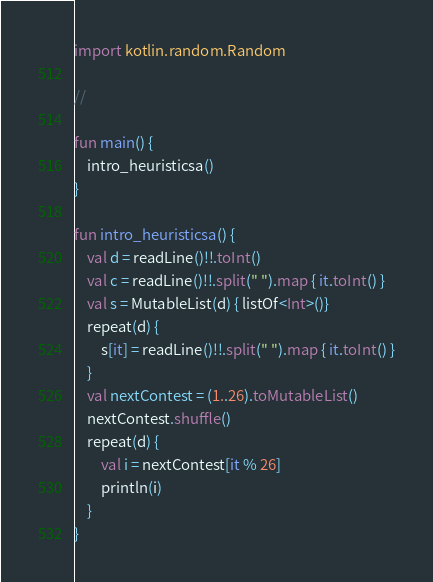Convert code to text. <code><loc_0><loc_0><loc_500><loc_500><_Kotlin_>import kotlin.random.Random

//

fun main() {
    intro_heuristicsa()
}

fun intro_heuristicsa() {
    val d = readLine()!!.toInt()
    val c = readLine()!!.split(" ").map { it.toInt() }
    val s = MutableList(d) { listOf<Int>()}
    repeat(d) {
        s[it] = readLine()!!.split(" ").map { it.toInt() }
    }
    val nextContest = (1..26).toMutableList()
    nextContest.shuffle()
    repeat(d) {
        val i = nextContest[it % 26]
        println(i)
    }
}
</code> 